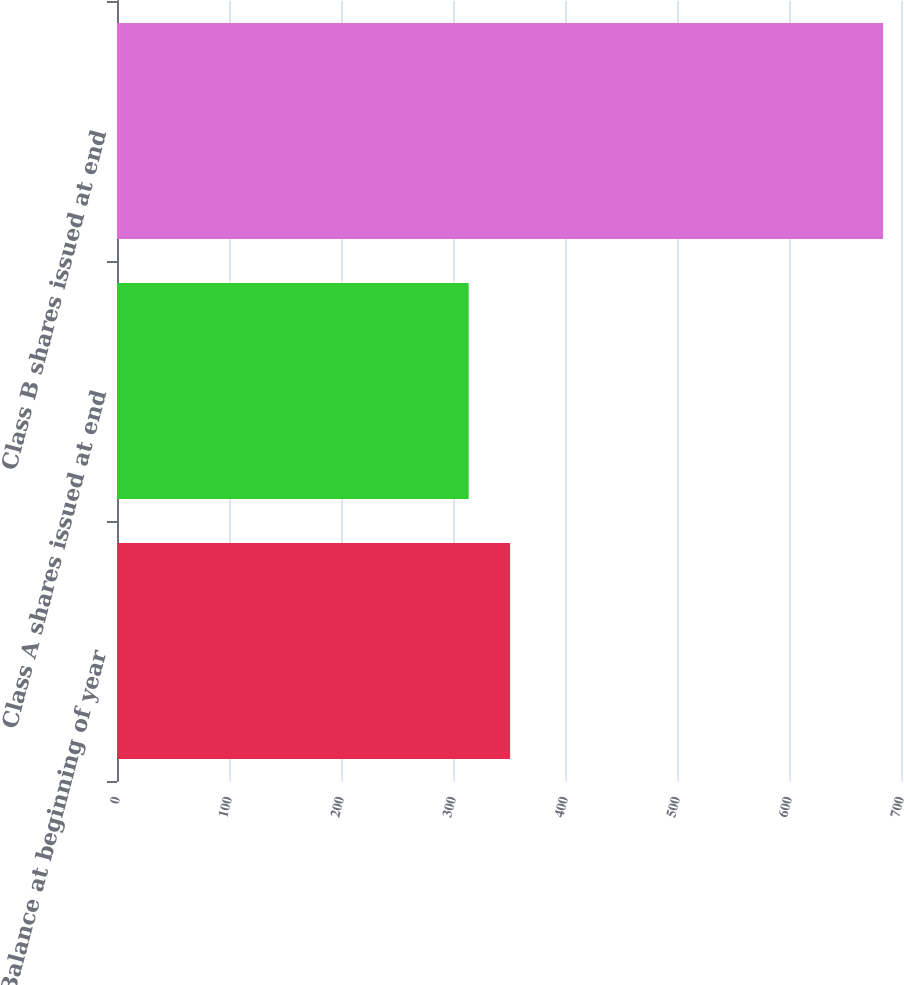Convert chart. <chart><loc_0><loc_0><loc_500><loc_500><bar_chart><fcel>Balance at beginning of year<fcel>Class A shares issued at end<fcel>Class B shares issued at end<nl><fcel>351<fcel>314<fcel>684<nl></chart> 